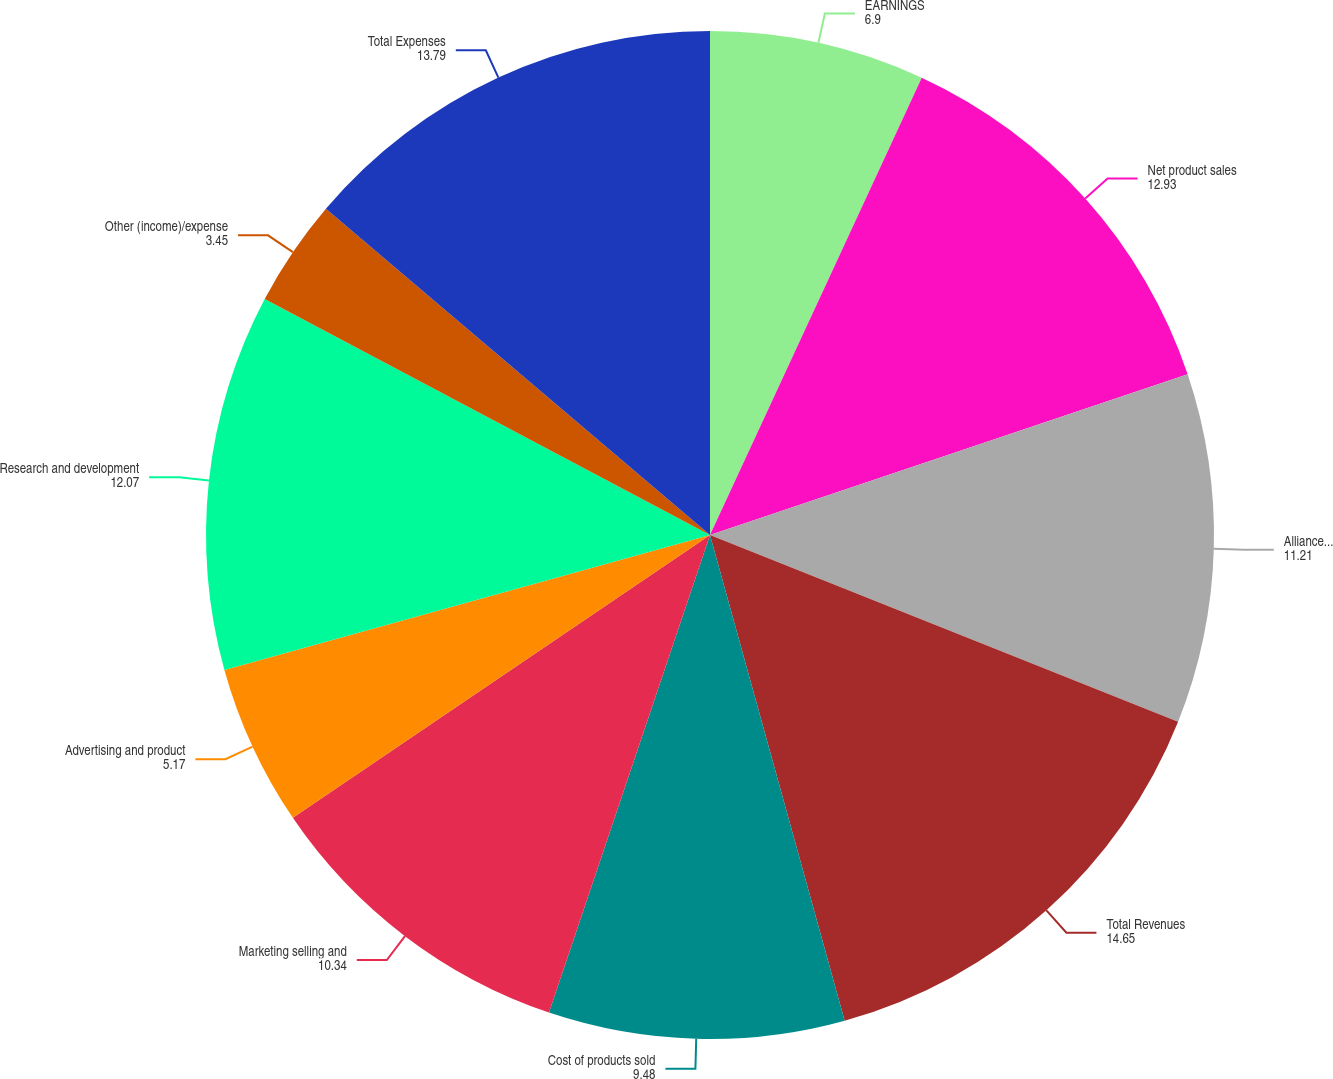Convert chart. <chart><loc_0><loc_0><loc_500><loc_500><pie_chart><fcel>EARNINGS<fcel>Net product sales<fcel>Alliance and other revenues<fcel>Total Revenues<fcel>Cost of products sold<fcel>Marketing selling and<fcel>Advertising and product<fcel>Research and development<fcel>Other (income)/expense<fcel>Total Expenses<nl><fcel>6.9%<fcel>12.93%<fcel>11.21%<fcel>14.65%<fcel>9.48%<fcel>10.34%<fcel>5.17%<fcel>12.07%<fcel>3.45%<fcel>13.79%<nl></chart> 